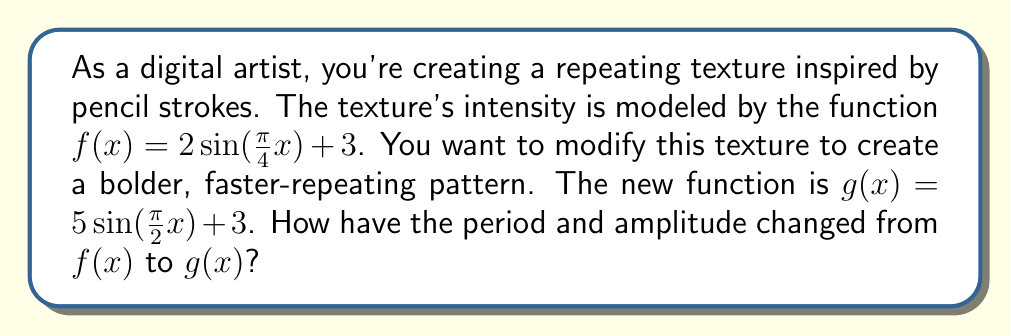Provide a solution to this math problem. Let's analyze the changes step-by-step:

1) For a sine function in the form $a\sin(bx) + c$:
   - The amplitude is $|a|$
   - The period is $\frac{2\pi}{|b|}$

2) For $f(x) = 2\sin(\frac{\pi}{4}x) + 3$:
   - Amplitude: $|2| = 2$
   - Period: $\frac{2\pi}{|\frac{\pi}{4}|} = 8$

3) For $g(x) = 5\sin(\frac{\pi}{2}x) + 3$:
   - Amplitude: $|5| = 5$
   - Period: $\frac{2\pi}{|\frac{\pi}{2}|} = 4$

4) Comparing the changes:
   - Amplitude: Changed from 2 to 5, an increase of 3 or 2.5 times the original
   - Period: Changed from 8 to 4, a decrease of 4 or half the original

Thus, the amplitude has increased by a factor of 2.5, and the period has decreased by a factor of 0.5 (halved).
Answer: Amplitude increased by factor of 2.5; period decreased by factor of 0.5 